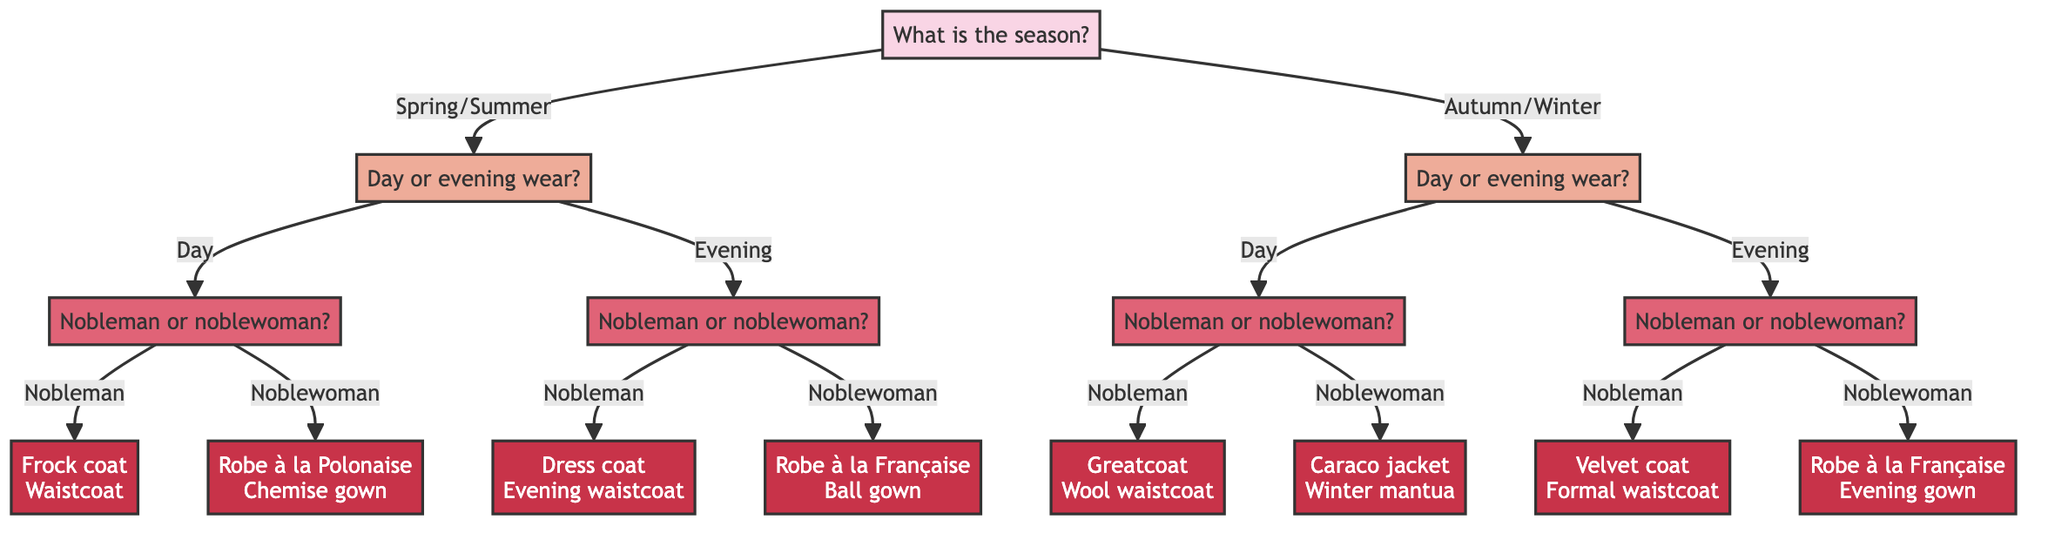What is the first question in the decision tree? The diagram begins with the question about the season, which is asked to categorize the garment styles based on seasonal trends. Thus, the first question is "What is the season?"
Answer: What is the season? How many options are available for the "Is the garment for day or evening wear?" node? At this node, there are two options provided: "Day" and "Evening". Thus, the total count of options at this point is two.
Answer: Two What styles are available for a noblewoman's evening attire? If we follow the evening path for a noblewoman, the options lead us to the "Robe à la Française" and "Ball gown". Hence, these two styles are specified for noblewomen in the evening.
Answer: Robe à la Française, Ball gown Which fabric is used for the Frock coat? The node for the Frock coat specifically mentions the fabrics suitable for it: "light wool" and "linen". Therefore, these are the fabrics associated with the Frock coat.
Answer: Light wool, linen If the season is Autumn/Winter and the garment is for a nobleman, what are the styles available? Following the path for Autumn/Winter and selecting “Day” for a nobleman leads to "Greatcoat" and "Wool waistcoat", while choosing "Evening" for a nobleman leads to "Velvet coat" and "Formal waistcoat". Both options reveal a total of four potential styles.
Answer: Greatcoat, Wool waistcoat, Velvet coat, Formal waistcoat What type of garment is made from silk and has embellished sleeves? The diagram indicates that a "Dress coat" is the garment made of "silk" and features "embellished sleeves". Hence, it refers to this specific style.
Answer: Dress coat What question follows after choosing "Evening" wear? After selecting "Evening" wear, the next question posed is "Is the garment for a nobleman or noblewoman?" This query helps further refine the choices for evening attire.
Answer: Is the garment for a nobleman or noblewoman? Which style is associated with fabrics of taffeta and brocade for noblewomen's evening wear? Within the evening choices for noblewomen, the "Robe à la Française" is specifically noted as being made from "taffeta" and "brocade". This indicates its fabric composition.
Answer: Robe à la Française 